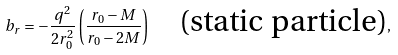<formula> <loc_0><loc_0><loc_500><loc_500>b _ { r } = - \frac { q ^ { 2 } } { 2 r _ { 0 } ^ { 2 } } \left ( \frac { r _ { 0 } - M } { r _ { 0 } - 2 M } \right ) \quad \text {(static particle)} ,</formula> 